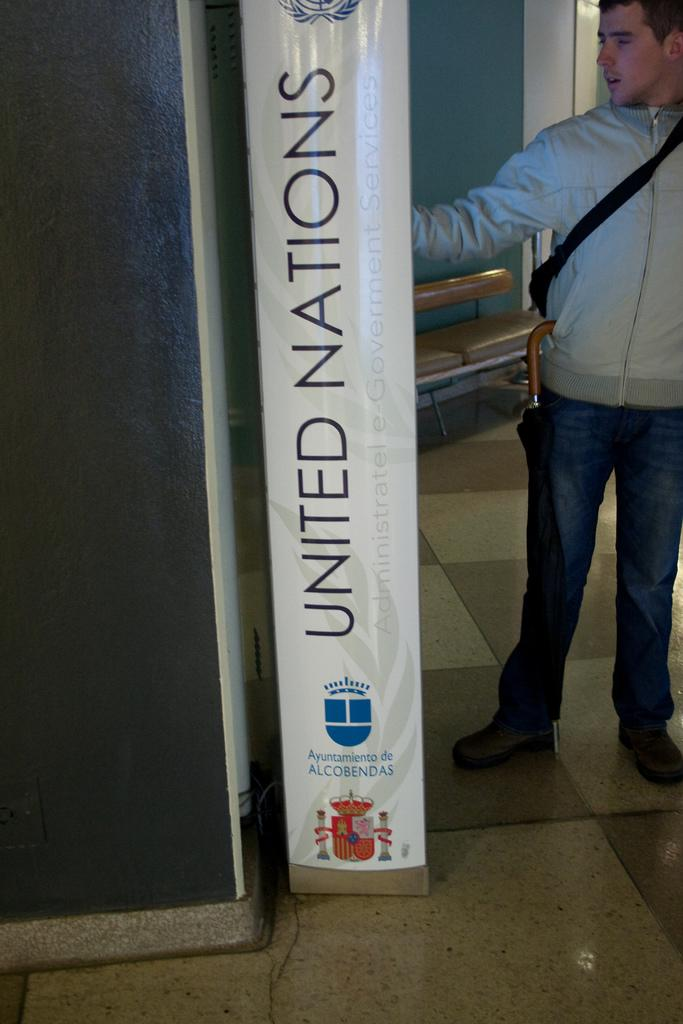<image>
Render a clear and concise summary of the photo. A man is looking at a panel by the wall that says United Nations on the side. 